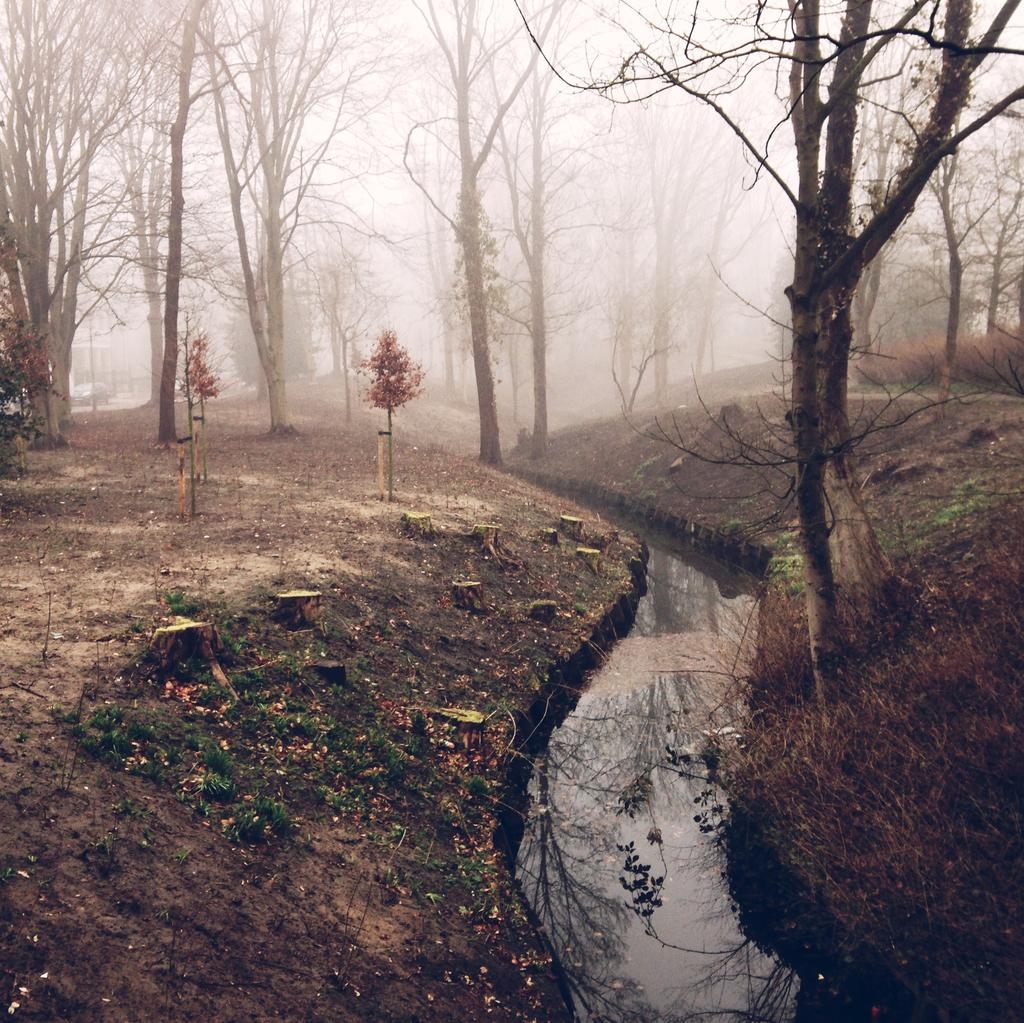What is the primary element in the image? There is water in the image. What type of vegetation is near the water? There is grass beside the water. What other natural elements can be seen in the image? There are trees in the image. What else is visible in the image besides the water and vegetation? There are objects visible in the image. What can be seen in the background of the image? The sky is visible in the background of the image. What type of rings are being worn by the trees in the image? There are no rings visible on the trees in the image. How does the crook interact with the water in the image? There is no crook present in the image. 